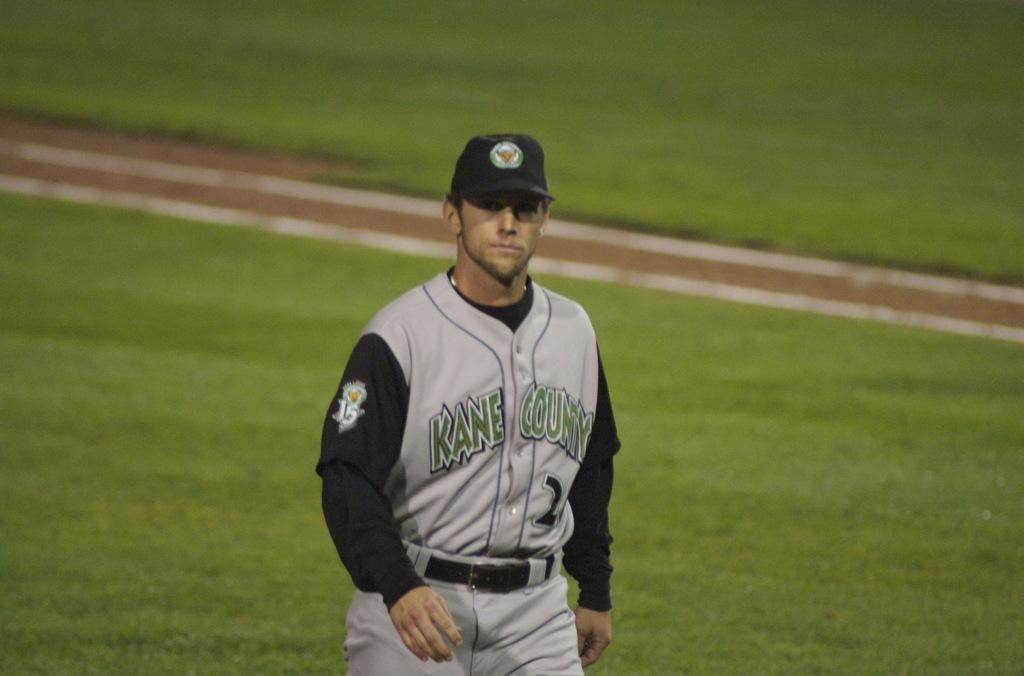What is the name of this team?
Your answer should be compact. Kane county. What county is this team from?
Offer a terse response. Kane. 